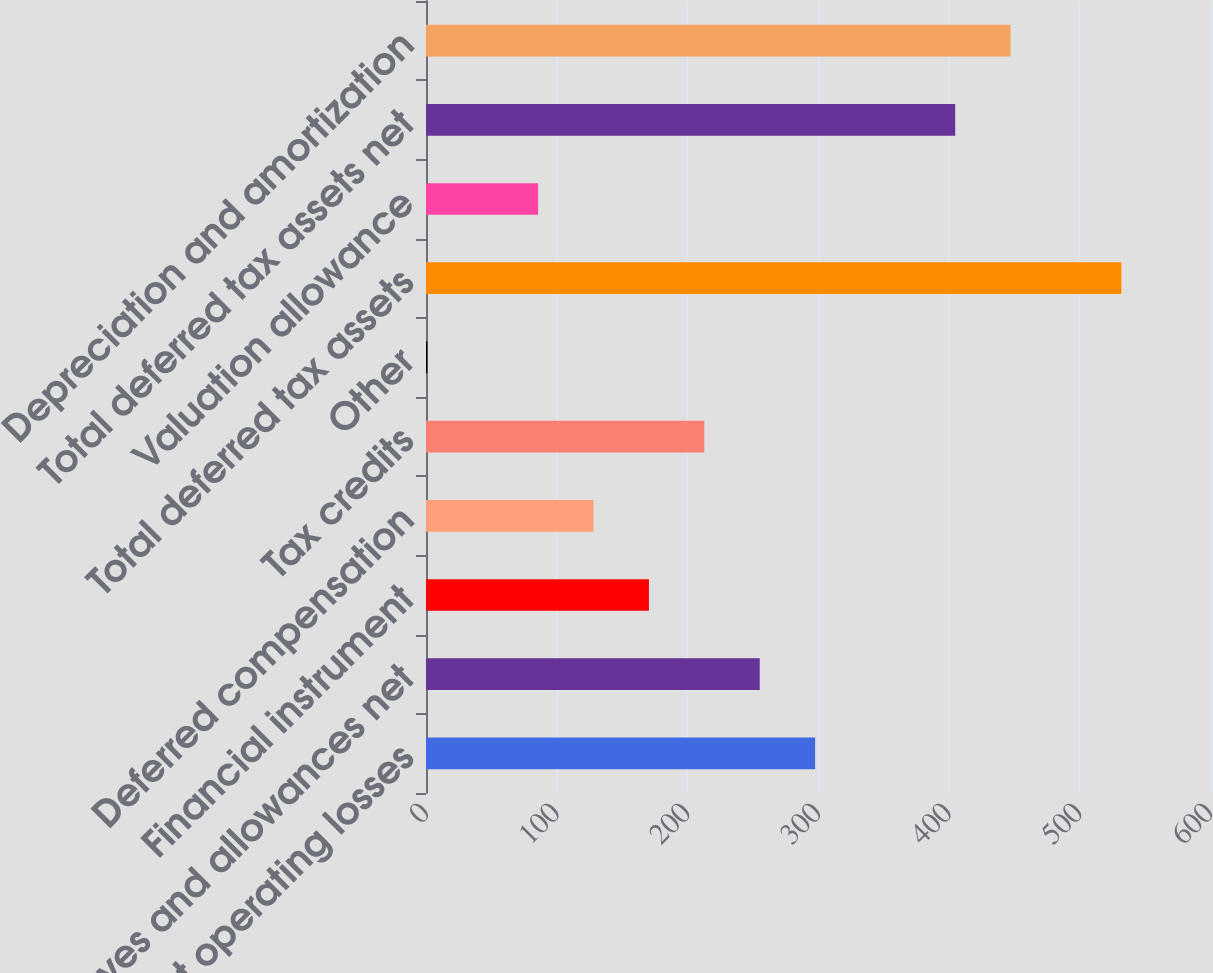<chart> <loc_0><loc_0><loc_500><loc_500><bar_chart><fcel>Net operating losses<fcel>Reserves and allowances net<fcel>Financial instrument<fcel>Deferred compensation<fcel>Tax credits<fcel>Other<fcel>Total deferred tax assets<fcel>Valuation allowance<fcel>Total deferred tax assets net<fcel>Depreciation and amortization<nl><fcel>297.8<fcel>255.4<fcel>170.6<fcel>128.2<fcel>213<fcel>1<fcel>532.2<fcel>85.8<fcel>405<fcel>447.4<nl></chart> 